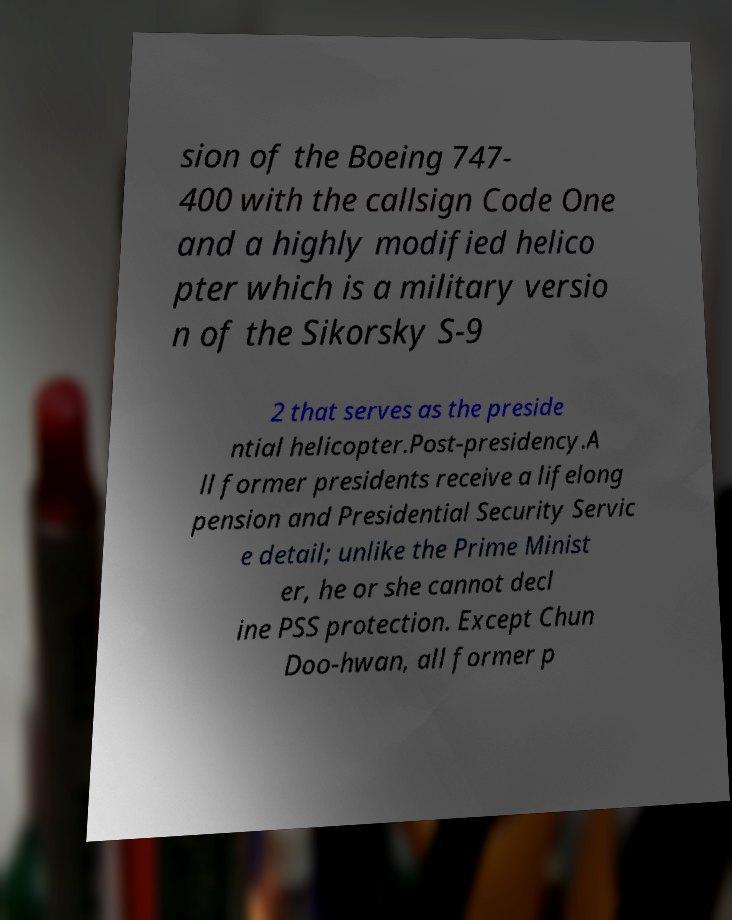Can you accurately transcribe the text from the provided image for me? sion of the Boeing 747- 400 with the callsign Code One and a highly modified helico pter which is a military versio n of the Sikorsky S-9 2 that serves as the preside ntial helicopter.Post-presidency.A ll former presidents receive a lifelong pension and Presidential Security Servic e detail; unlike the Prime Minist er, he or she cannot decl ine PSS protection. Except Chun Doo-hwan, all former p 